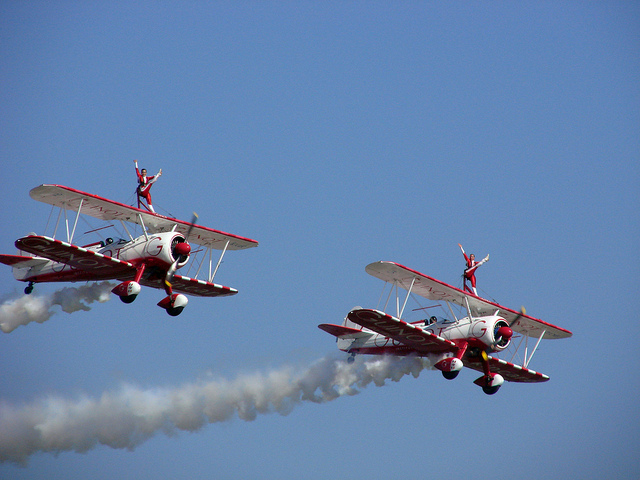<image>What is being emitted from the backs of these planes? It is not clear what is being emitted from the backs of these planes. It could be smoke or contrails. What are the name of these planes? It's unclear what the name of these planes are. They could be biplanes or crop dusters, but I can't be certain. What is being emitted from the backs of these planes? I don't know what is being emitted from the backs of these planes. It can be smoke or contrails. What are the name of these planes? I don't know the name of these planes. They can be called 'airplane', 'biplanes', 'wright brothers', 'biplane', or 'crop dusters'. 